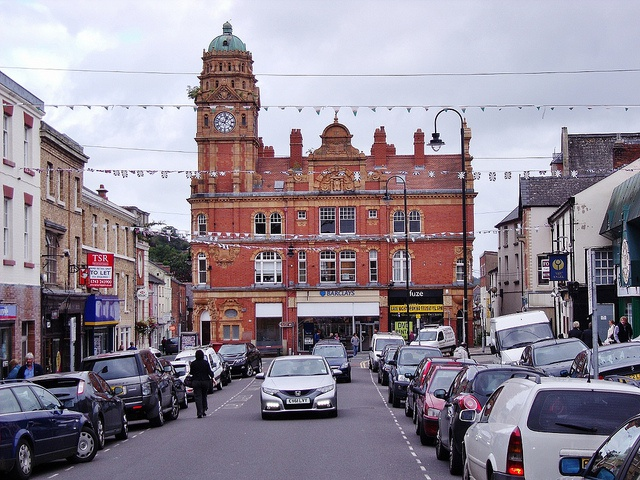Describe the objects in this image and their specific colors. I can see car in lavender, darkgray, navy, and black tones, car in lavender, black, darkgray, and gray tones, car in lavender, black, darkgray, and gray tones, car in lavender, black, gray, and darkgray tones, and car in lavender, darkgray, black, and gray tones in this image. 